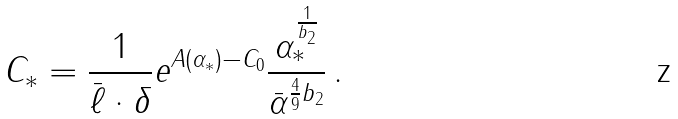<formula> <loc_0><loc_0><loc_500><loc_500>C _ { * } = \frac { 1 } { { \bar { \ell } } \cdot \delta } e ^ { A ( \alpha _ { * } ) - C _ { 0 } } \frac { \alpha _ { * } ^ { \frac { 1 } { b _ { 2 } } } } { { \bar { \alpha } ^ { \frac { 4 } { 9 } b _ { 2 } } } } \, .</formula> 